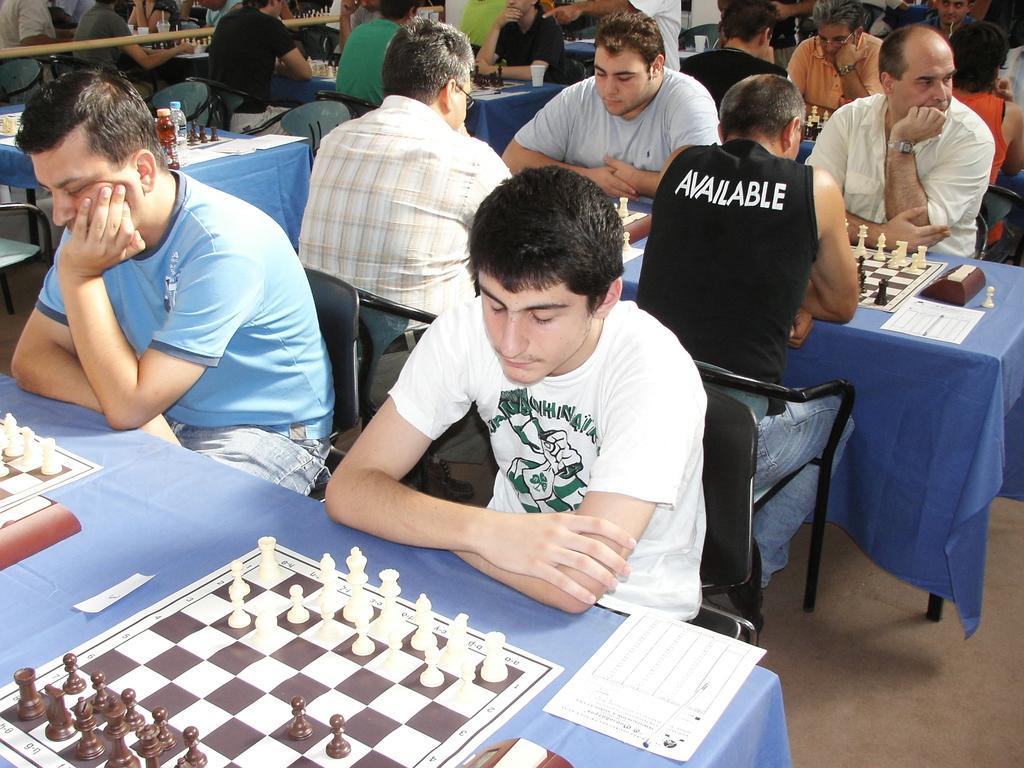Please provide a concise description of this image. This image consists of so many people who are playing chess. there are so many chess boards and chess coins placed on the tables. There are so many chairs, tables ,all of them are men, there is a paper placed in the bottom on the table and there is also a paper placed on the table which is on the right side there is a water bottle placed on the table which is on the left side. 